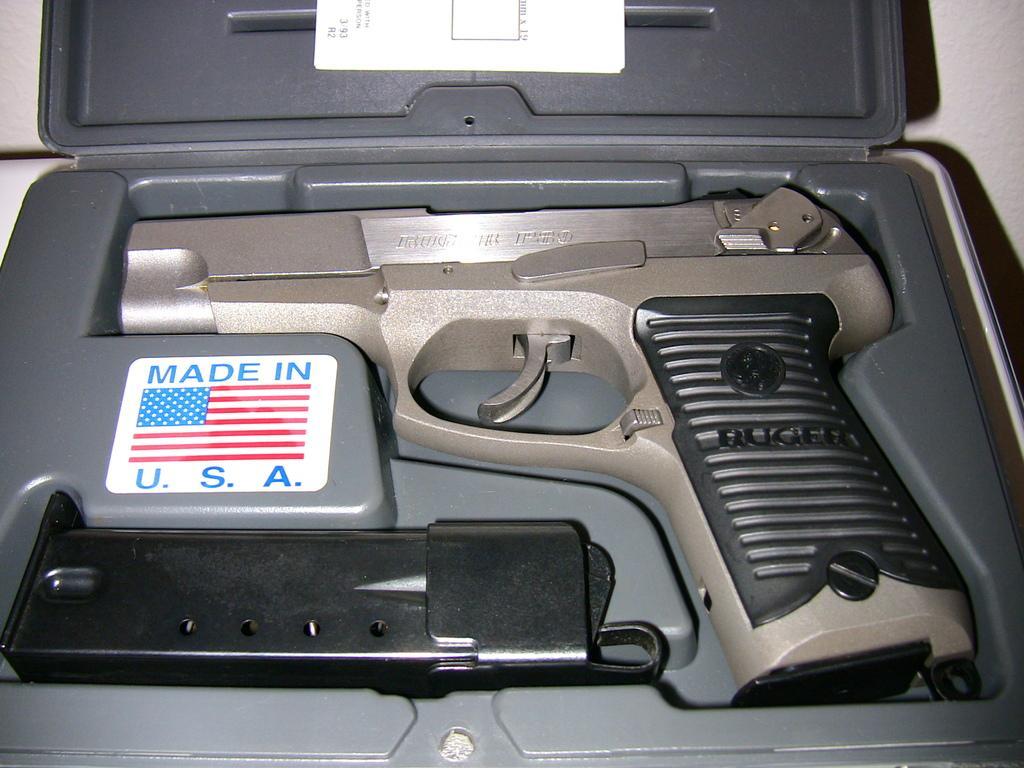Describe this image in one or two sentences. In the picture we can see a box with a gun and a magazine which is black in color and beside to the gun and written as made in USA flag symbol on the box. 